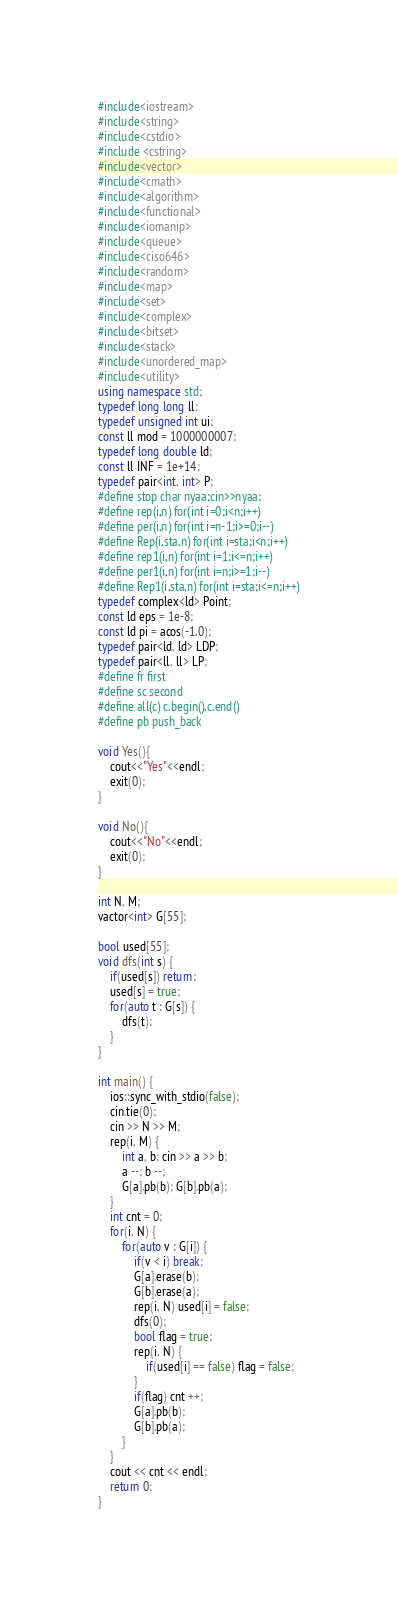<code> <loc_0><loc_0><loc_500><loc_500><_C++_>#include<iostream>
#include<string>
#include<cstdio>
#include <cstring>
#include<vector>
#include<cmath>
#include<algorithm>
#include<functional>
#include<iomanip>
#include<queue>
#include<ciso646>
#include<random>
#include<map>
#include<set>
#include<complex>
#include<bitset>
#include<stack>
#include<unordered_map>
#include<utility>
using namespace std;
typedef long long ll;
typedef unsigned int ui;
const ll mod = 1000000007;
typedef long double ld;
const ll INF = 1e+14;
typedef pair<int, int> P;
#define stop char nyaa;cin>>nyaa;
#define rep(i,n) for(int i=0;i<n;i++)
#define per(i,n) for(int i=n-1;i>=0;i--)
#define Rep(i,sta,n) for(int i=sta;i<n;i++)
#define rep1(i,n) for(int i=1;i<=n;i++)
#define per1(i,n) for(int i=n;i>=1;i--)
#define Rep1(i,sta,n) for(int i=sta;i<=n;i++)
typedef complex<ld> Point;
const ld eps = 1e-8;
const ld pi = acos(-1.0);
typedef pair<ld, ld> LDP;
typedef pair<ll, ll> LP;
#define fr first
#define sc second
#define all(c) c.begin(),c.end()
#define pb push_back

void Yes(){
	cout<<"Yes"<<endl;
	exit(0);
}
 
void No(){
	cout<<"No"<<endl;
	exit(0);
}

int N, M;
vactor<int> G[55];

bool used[55];
void dfs(int s) {
    if(used[s]) return;
    used[s] = true;
    for(auto t : G[s]) {
        dfs(t);
    }
}

int main() {
	ios::sync_with_stdio(false);
	cin.tie(0);
    cin >> N >> M;
    rep(i, M) {
        int a, b; cin >> a >> b;
        a --; b --;
        G[a].pb(b); G[b].pb(a);
    }
    int cnt = 0;
    for(i, N) {
        for(auto v : G[i]) {
            if(v < i) break;
            G[a].erase(b);
            G[b].erase(a);
            rep(i, N) used[i] = false;
            dfs(0);
            bool flag = true;
            rep(i, N) {
                if(used[i] == false) flag = false;
            }
            if(flag) cnt ++;
            G[a].pb(b);
            G[b].pb(a);
        }
    }
    cout << cnt << endl;
	return 0;
}</code> 